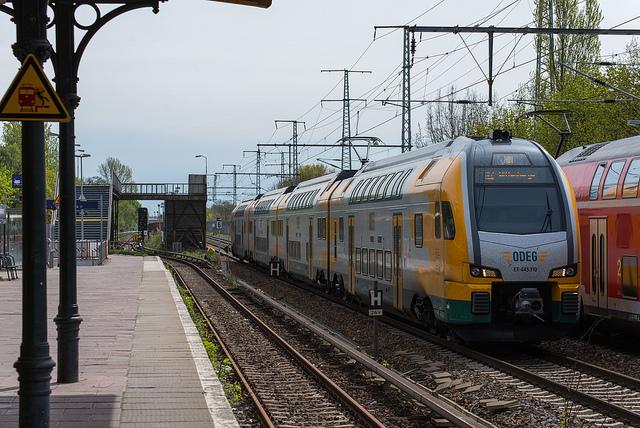How are the trains powered?
Concise answer only. Electricity. How many rails are there?
Answer briefly. 3. How would you describe the weather conditions?
Keep it brief. Cloudy. Are the trains on time?
Be succinct. Yes. How many trains are in the picture?
Give a very brief answer. 2. How many tracks?
Quick response, please. 3. 